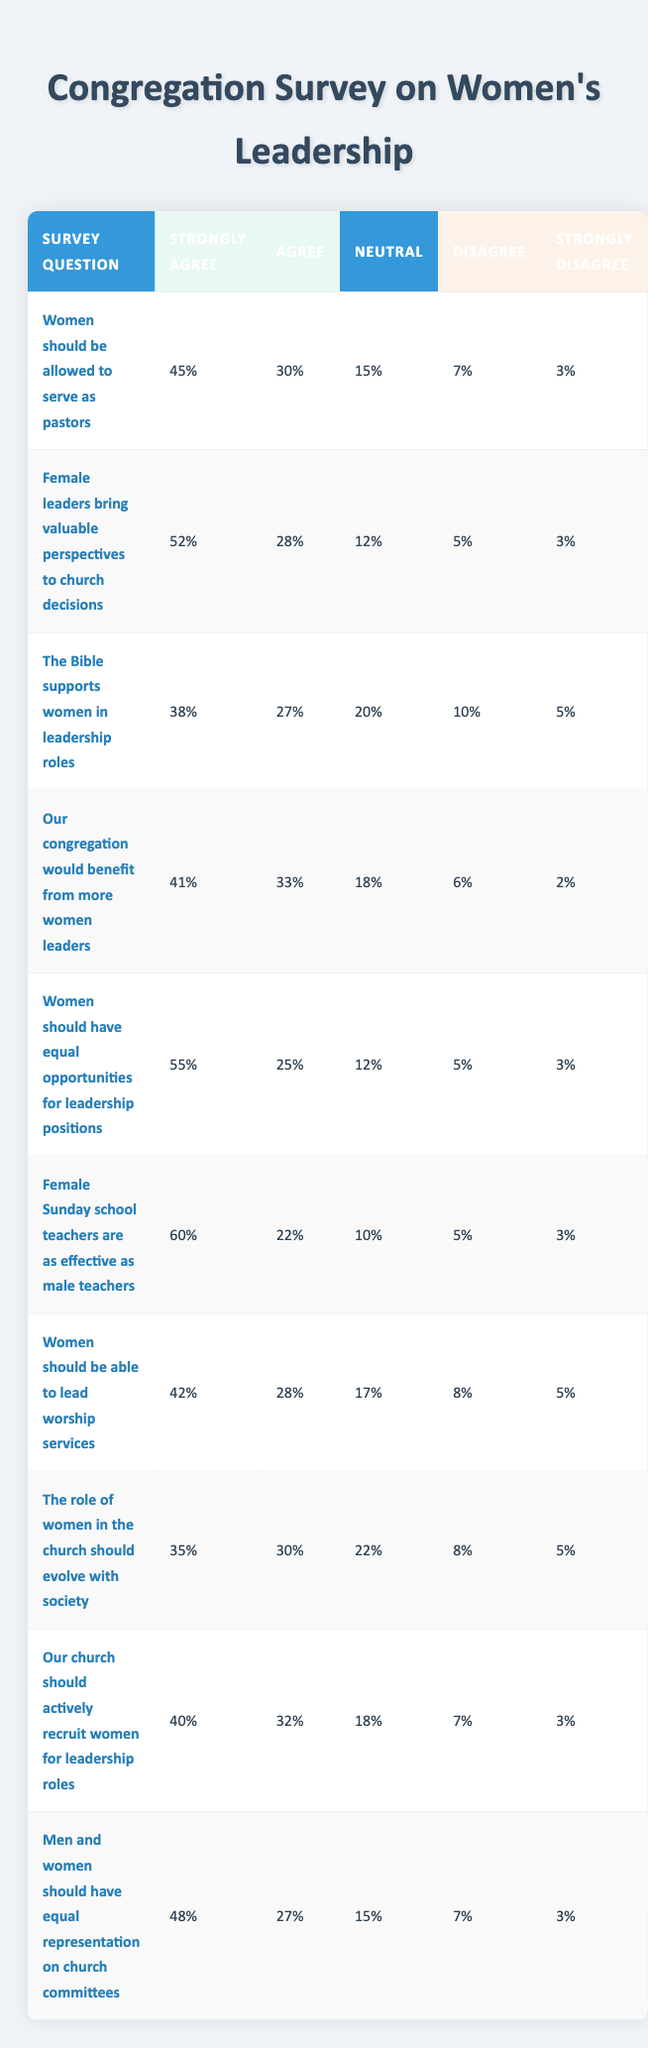What percentage of respondents strongly agree that women should be allowed to serve as pastors? The table indicates that 45% of respondents strongly agree with the statement that women should be allowed to serve as pastors.
Answer: 45% How many respondents expressed a neutral opinion on whether female leaders bring valuable perspectives to church decisions? According to the table, 12% of respondents selected the neutral option regarding the statement about female leaders’ perspectives.
Answer: 12% What is the total percentage of respondents who agree or strongly agree that women should have equal opportunities for leadership positions? To find this, we add the percentages for "Strongly Agree" (55%) and "Agree" (25%). So, 55% + 25% = 80%.
Answer: 80% Is it true that a higher percentage of respondents strongly agree that female Sunday school teachers are as effective as male teachers compared to women leading worship services? From the table, 60% strongly agree that female Sunday school teachers are effective, while only 42% strongly agree that women should lead worship services. Since 60% is greater than 42%, the statement is true.
Answer: Yes What’s the average percentage of respondents who either disagree or strongly disagree across all survey questions? To calculate this, we sum the percentages of "Disagree" and "Strongly Disagree" for each question. Adding them gives (7+3) + (5+3) + (10+5) + (6+2) + (5+3) + (5+3) + (8+5) + (8+5) + (7+3) + (7+3) = 5 + 8 + 15 + 8 + 8 + 8 + 13 + 10 + 10 + 10 = 72. Since there are 10 questions, the average is 72/10 = 7.2%.
Answer: 7.2% 